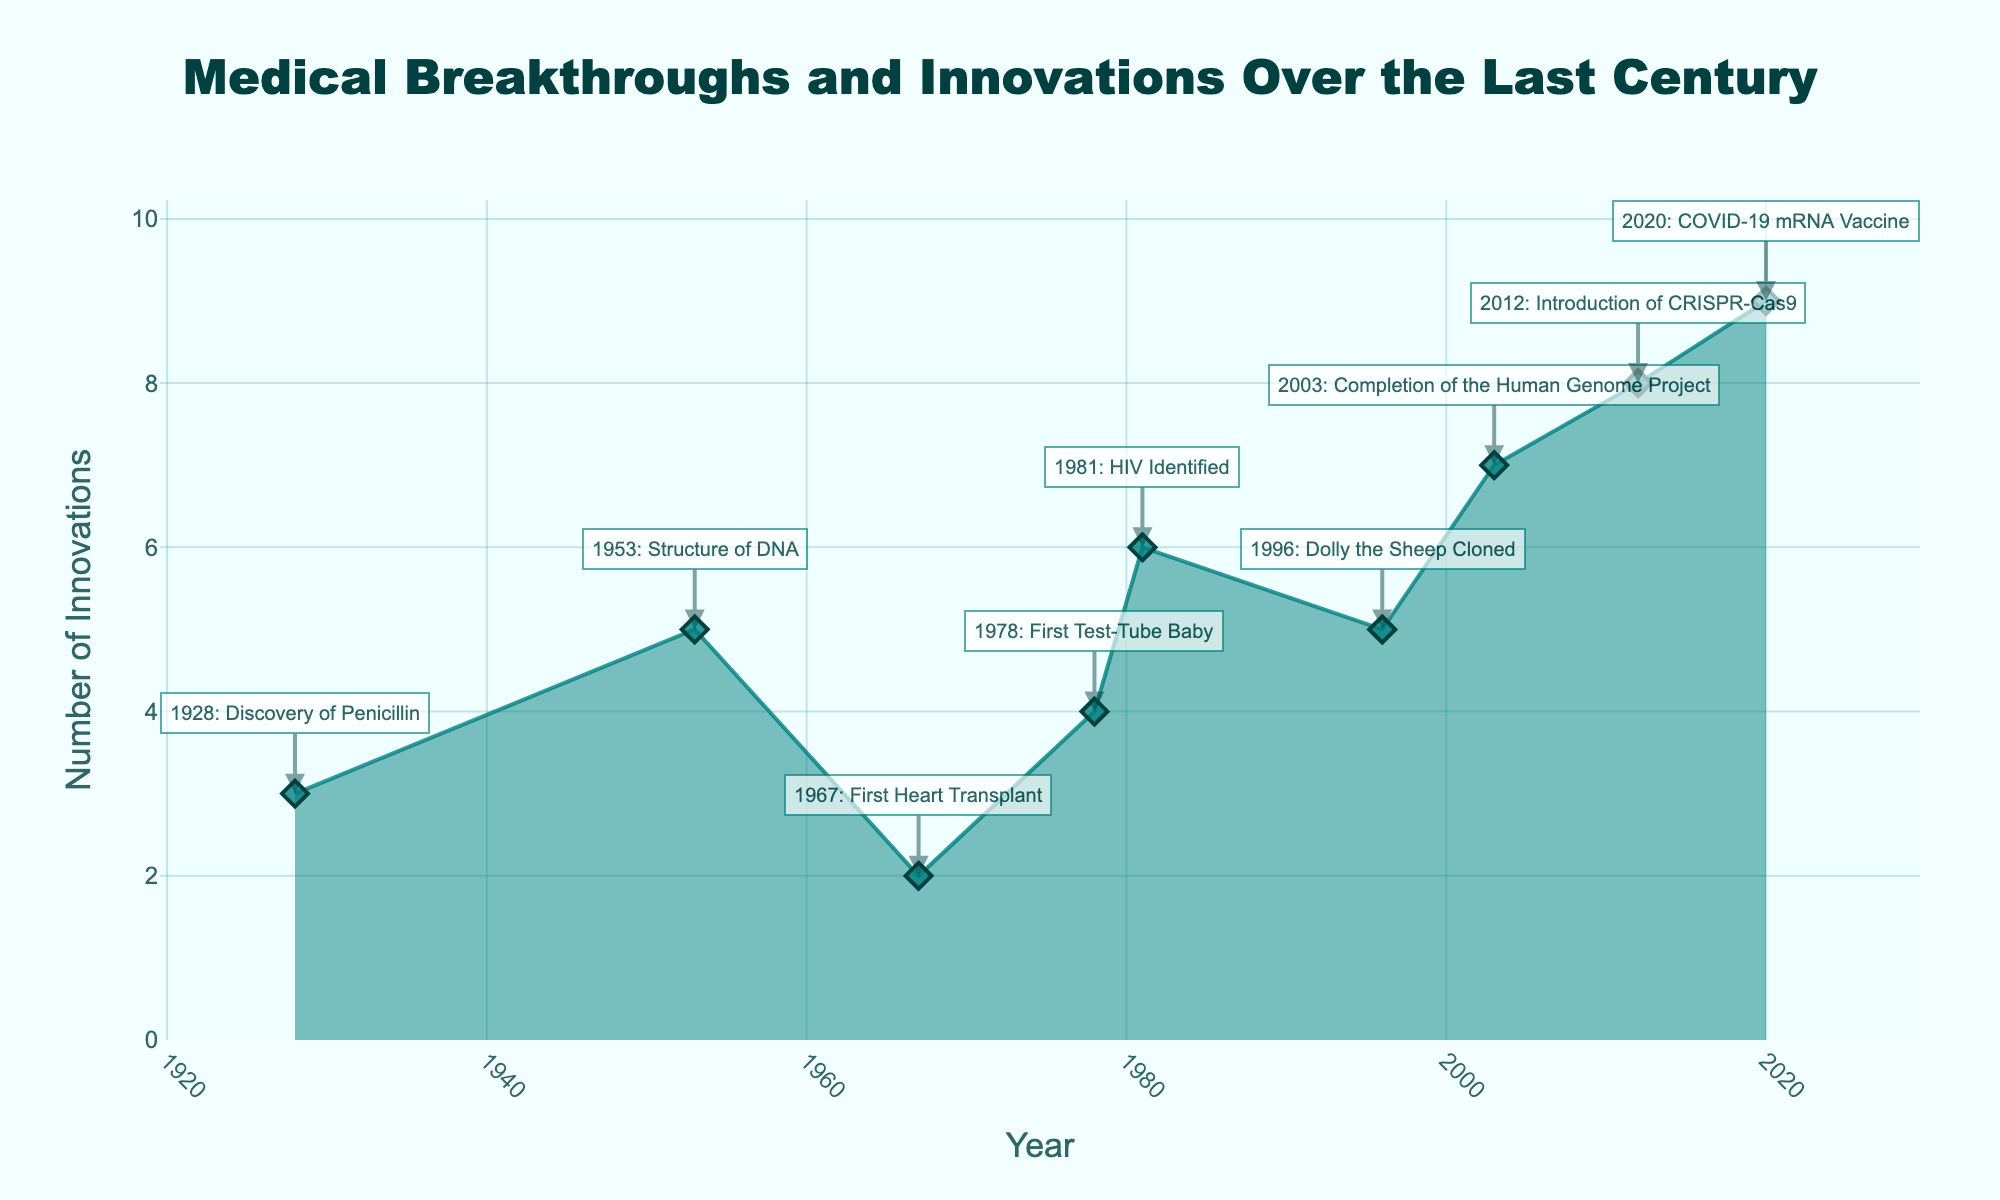What is the title of the chart? The title of the chart is usually located at the top center. In this case, it reads: 'Medical Breakthroughs and Innovations Over the Last Century'.
Answer: Medical Breakthroughs and Innovations Over the Last Century Which breakthrough has the highest number of innovations? Look for the highest point on the y-axis and see which breakthrough corresponds to that year. In the chart, the year 2020 shows the highest number of innovations related to the COVID-19 mRNA Vaccine.
Answer: COVID-19 mRNA Vaccine How many medical breakthroughs are listed on the chart? Count the number of data points or annotations present in the chart. There are 9 data points or breakthroughs annotated.
Answer: 9 What is the number of innovations associated with the discovery of Penicillin? Find the year 1928 on the x-axis and see the corresponding value on the y-axis. For 1928, the number of innovations is 3.
Answer: 3 Which influential figures are associated with the completion of the Human Genome Project? Look for the annotation or marker at the year 2003, which states the breakthrough and the influential figures. For 2003, the influential figures are Francis Collins & Craig Venter.
Answer: Francis Collins & Craig Venter Compare the number of innovations in 1981 and 1996. Which year had more innovations and by how much? Identify the data points for 1981 and 1996 and compare their heights on the y-axis. In 1981, there are 6 innovations and in 1996, there are 5 innovations. The difference is 1 innovation.
Answer: 1981 by 1 innovation What trend do you observe in the number of innovations from 1953 to 1978? Observe the height of the data points from 1953 to 1978. There is a slight increase in the number of innovations, moving from 5 in 1953 to 4 in 1978.
Answer: Slight decrease During which decade did the area chart first show a significant rise in the number of innovations? Examine the chart for the first significant upward trend. The 1980s show a notable rise, specifically around the year 1981.
Answer: 1980s What is the median number of innovations over the entire century? To find the median, list all the number of innovations and find the middle value. The values are 3, 5, 2, 4, 6, 5, 7, 8, 9. The middle value is 5.
Answer: 5 